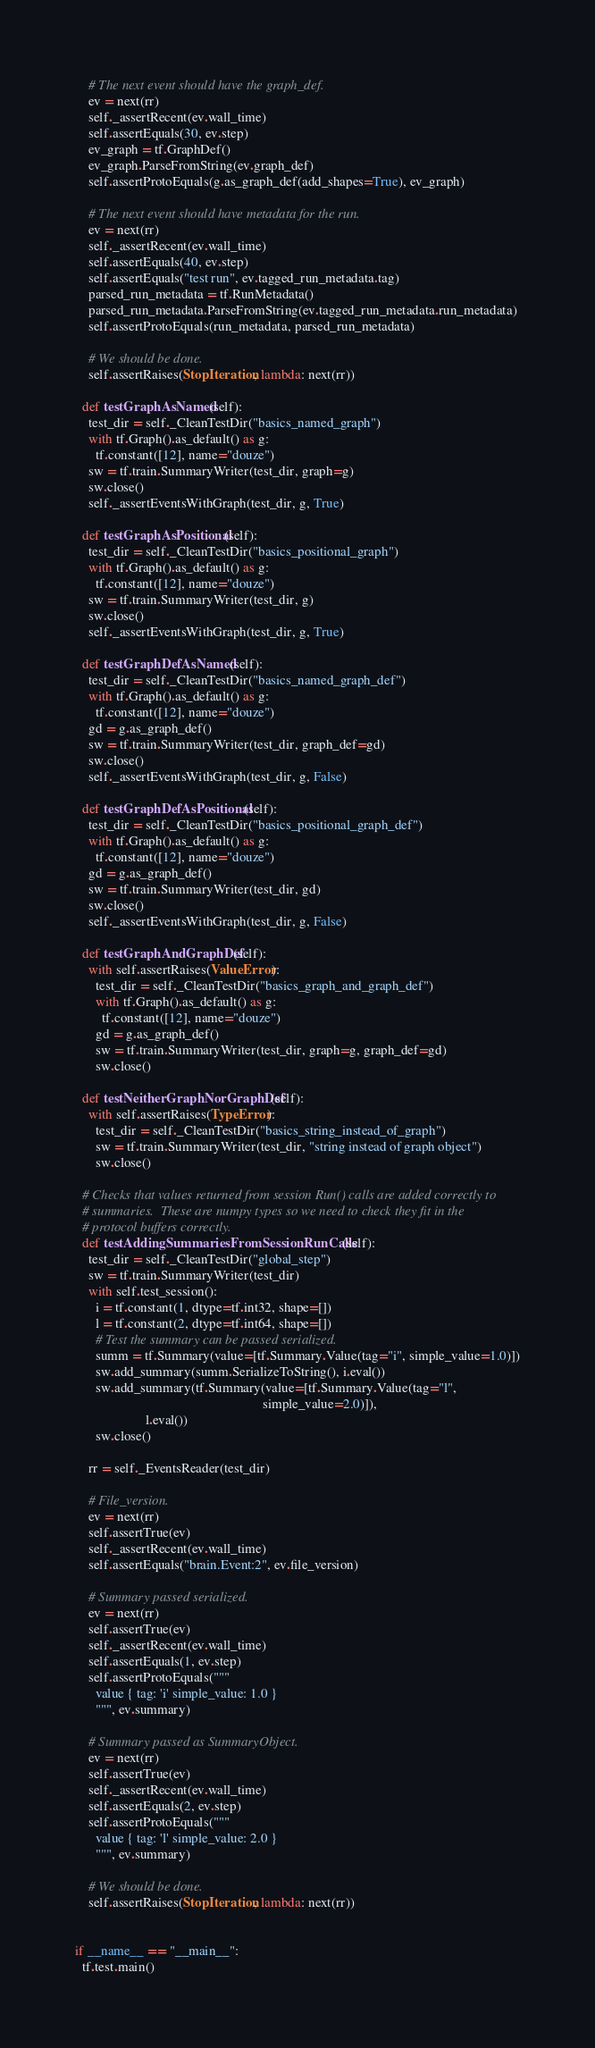Convert code to text. <code><loc_0><loc_0><loc_500><loc_500><_Python_>    # The next event should have the graph_def.
    ev = next(rr)
    self._assertRecent(ev.wall_time)
    self.assertEquals(30, ev.step)
    ev_graph = tf.GraphDef()
    ev_graph.ParseFromString(ev.graph_def)
    self.assertProtoEquals(g.as_graph_def(add_shapes=True), ev_graph)

    # The next event should have metadata for the run.
    ev = next(rr)
    self._assertRecent(ev.wall_time)
    self.assertEquals(40, ev.step)
    self.assertEquals("test run", ev.tagged_run_metadata.tag)
    parsed_run_metadata = tf.RunMetadata()
    parsed_run_metadata.ParseFromString(ev.tagged_run_metadata.run_metadata)
    self.assertProtoEquals(run_metadata, parsed_run_metadata)

    # We should be done.
    self.assertRaises(StopIteration, lambda: next(rr))

  def testGraphAsNamed(self):
    test_dir = self._CleanTestDir("basics_named_graph")
    with tf.Graph().as_default() as g:
      tf.constant([12], name="douze")
    sw = tf.train.SummaryWriter(test_dir, graph=g)
    sw.close()
    self._assertEventsWithGraph(test_dir, g, True)

  def testGraphAsPositional(self):
    test_dir = self._CleanTestDir("basics_positional_graph")
    with tf.Graph().as_default() as g:
      tf.constant([12], name="douze")
    sw = tf.train.SummaryWriter(test_dir, g)
    sw.close()
    self._assertEventsWithGraph(test_dir, g, True)

  def testGraphDefAsNamed(self):
    test_dir = self._CleanTestDir("basics_named_graph_def")
    with tf.Graph().as_default() as g:
      tf.constant([12], name="douze")
    gd = g.as_graph_def()
    sw = tf.train.SummaryWriter(test_dir, graph_def=gd)
    sw.close()
    self._assertEventsWithGraph(test_dir, g, False)

  def testGraphDefAsPositional(self):
    test_dir = self._CleanTestDir("basics_positional_graph_def")
    with tf.Graph().as_default() as g:
      tf.constant([12], name="douze")
    gd = g.as_graph_def()
    sw = tf.train.SummaryWriter(test_dir, gd)
    sw.close()
    self._assertEventsWithGraph(test_dir, g, False)

  def testGraphAndGraphDef(self):
    with self.assertRaises(ValueError):
      test_dir = self._CleanTestDir("basics_graph_and_graph_def")
      with tf.Graph().as_default() as g:
        tf.constant([12], name="douze")
      gd = g.as_graph_def()
      sw = tf.train.SummaryWriter(test_dir, graph=g, graph_def=gd)
      sw.close()

  def testNeitherGraphNorGraphDef(self):
    with self.assertRaises(TypeError):
      test_dir = self._CleanTestDir("basics_string_instead_of_graph")
      sw = tf.train.SummaryWriter(test_dir, "string instead of graph object")
      sw.close()

  # Checks that values returned from session Run() calls are added correctly to
  # summaries.  These are numpy types so we need to check they fit in the
  # protocol buffers correctly.
  def testAddingSummariesFromSessionRunCalls(self):
    test_dir = self._CleanTestDir("global_step")
    sw = tf.train.SummaryWriter(test_dir)
    with self.test_session():
      i = tf.constant(1, dtype=tf.int32, shape=[])
      l = tf.constant(2, dtype=tf.int64, shape=[])
      # Test the summary can be passed serialized.
      summ = tf.Summary(value=[tf.Summary.Value(tag="i", simple_value=1.0)])
      sw.add_summary(summ.SerializeToString(), i.eval())
      sw.add_summary(tf.Summary(value=[tf.Summary.Value(tag="l",
                                                        simple_value=2.0)]),
                     l.eval())
      sw.close()

    rr = self._EventsReader(test_dir)

    # File_version.
    ev = next(rr)
    self.assertTrue(ev)
    self._assertRecent(ev.wall_time)
    self.assertEquals("brain.Event:2", ev.file_version)

    # Summary passed serialized.
    ev = next(rr)
    self.assertTrue(ev)
    self._assertRecent(ev.wall_time)
    self.assertEquals(1, ev.step)
    self.assertProtoEquals("""
      value { tag: 'i' simple_value: 1.0 }
      """, ev.summary)

    # Summary passed as SummaryObject.
    ev = next(rr)
    self.assertTrue(ev)
    self._assertRecent(ev.wall_time)
    self.assertEquals(2, ev.step)
    self.assertProtoEquals("""
      value { tag: 'l' simple_value: 2.0 }
      """, ev.summary)

    # We should be done.
    self.assertRaises(StopIteration, lambda: next(rr))


if __name__ == "__main__":
  tf.test.main()
</code> 